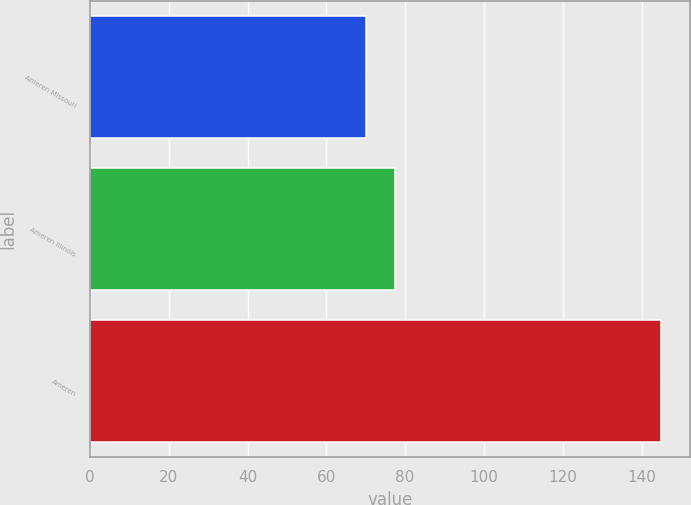Convert chart to OTSL. <chart><loc_0><loc_0><loc_500><loc_500><bar_chart><fcel>Ameren Missouri<fcel>Ameren Illinois<fcel>Ameren<nl><fcel>70<fcel>77.5<fcel>145<nl></chart> 